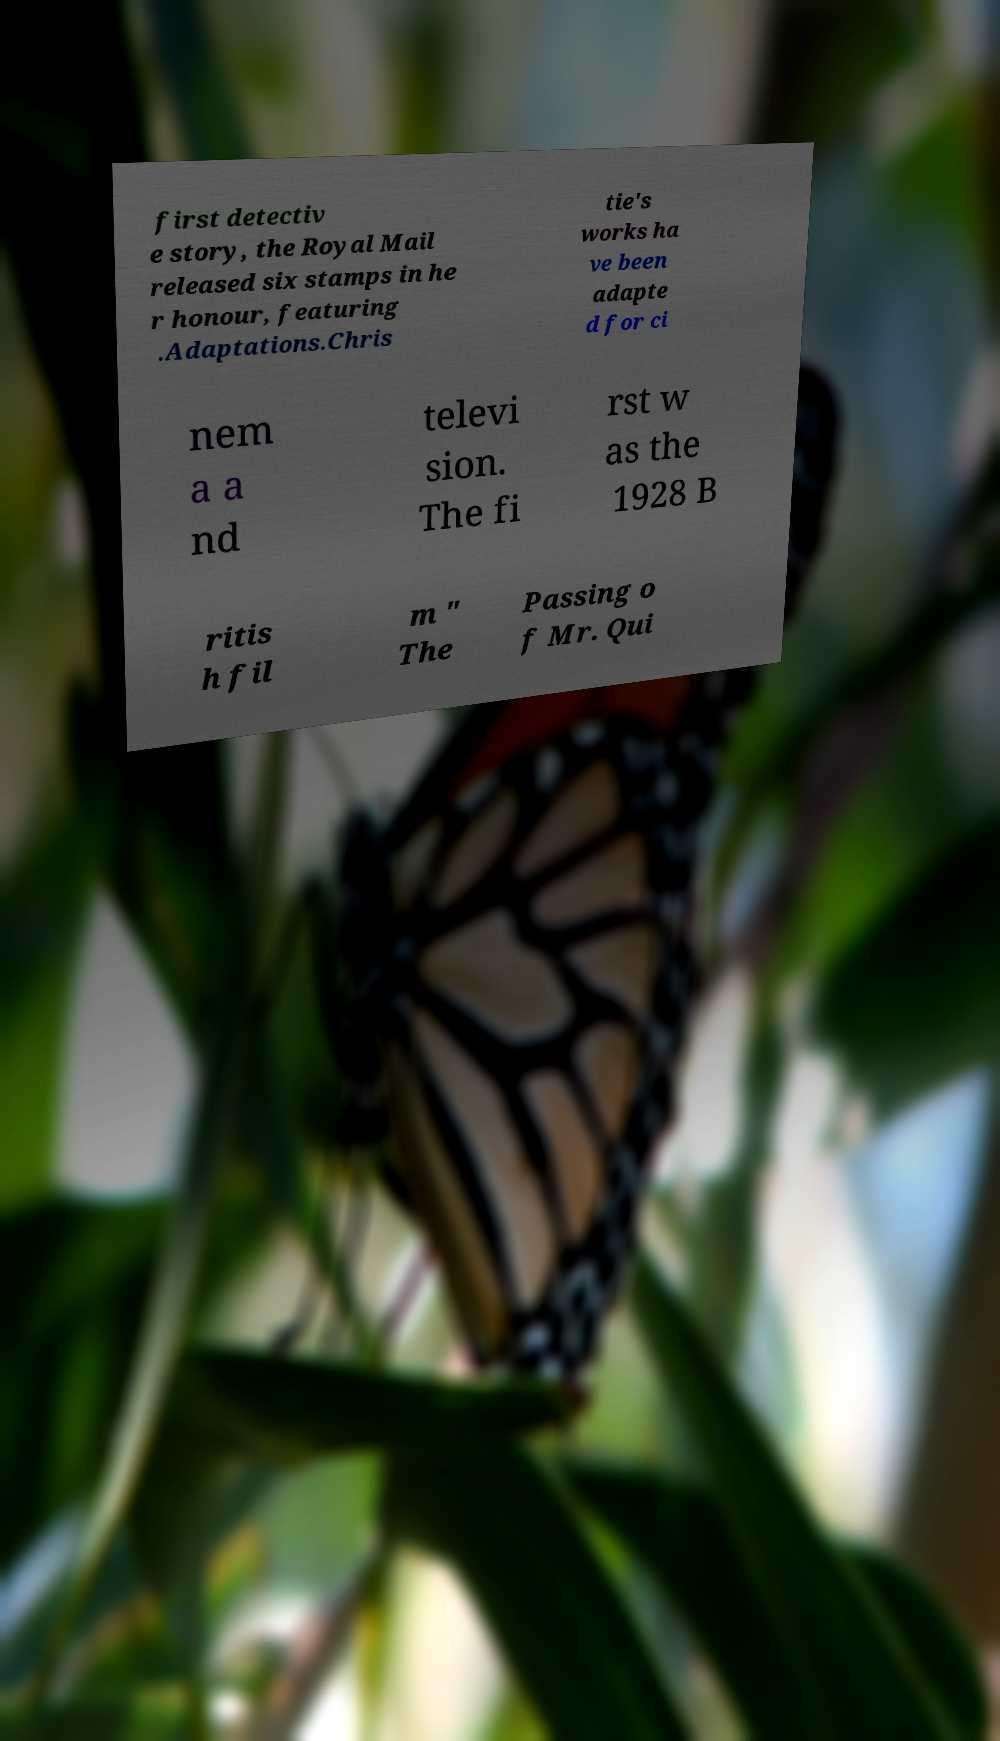Please read and relay the text visible in this image. What does it say? first detectiv e story, the Royal Mail released six stamps in he r honour, featuring .Adaptations.Chris tie's works ha ve been adapte d for ci nem a a nd televi sion. The fi rst w as the 1928 B ritis h fil m " The Passing o f Mr. Qui 